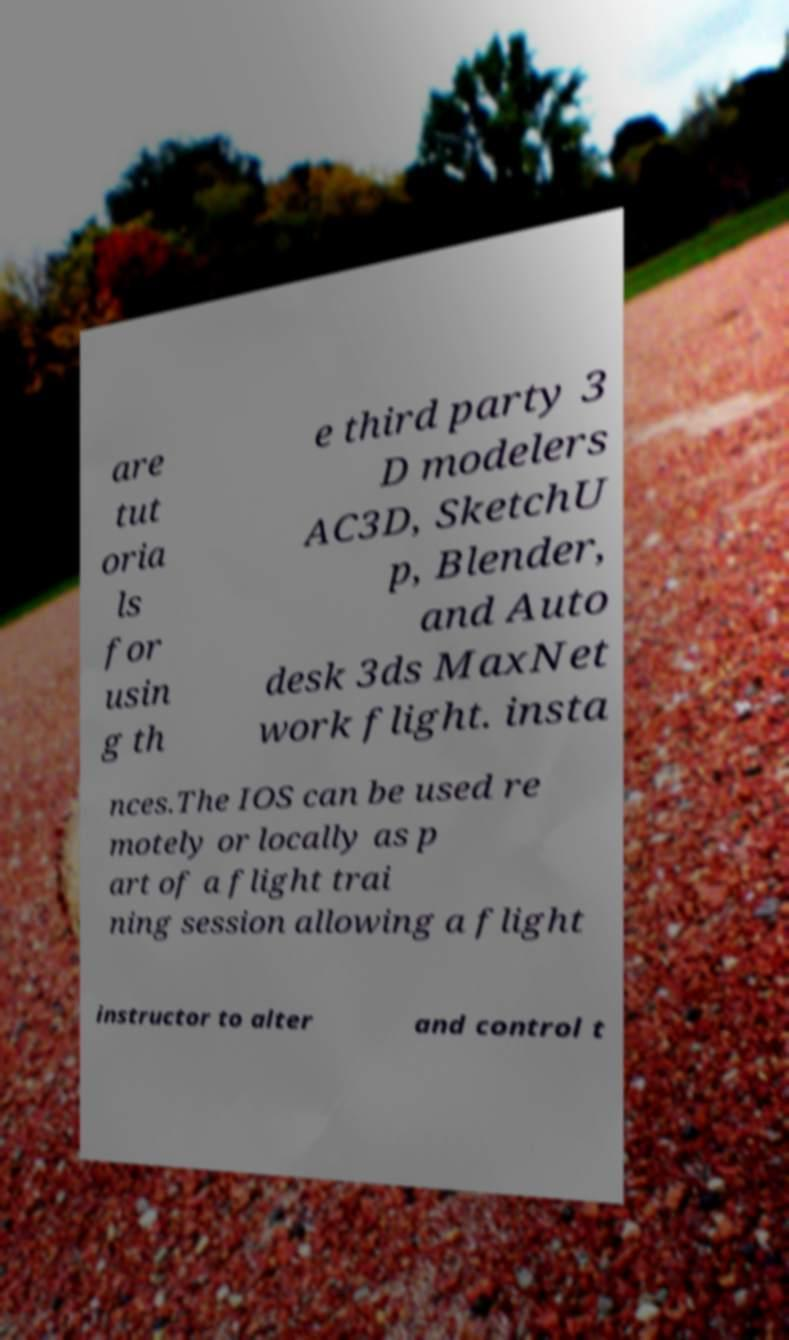I need the written content from this picture converted into text. Can you do that? are tut oria ls for usin g th e third party 3 D modelers AC3D, SketchU p, Blender, and Auto desk 3ds MaxNet work flight. insta nces.The IOS can be used re motely or locally as p art of a flight trai ning session allowing a flight instructor to alter and control t 